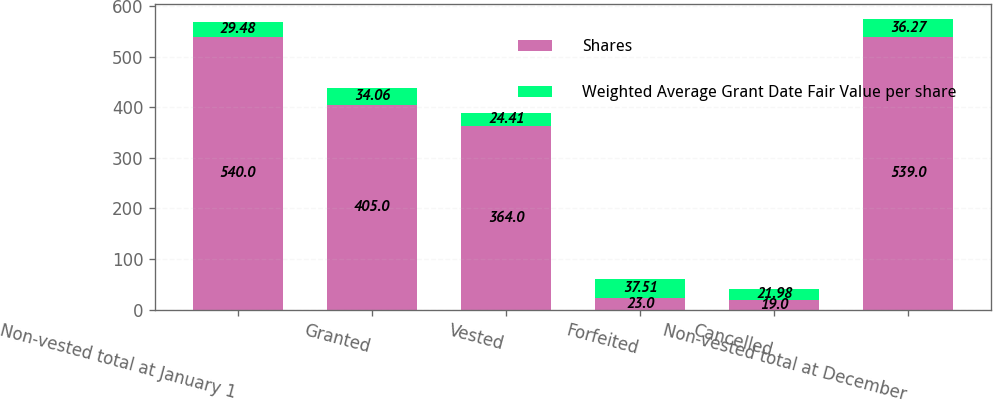Convert chart. <chart><loc_0><loc_0><loc_500><loc_500><stacked_bar_chart><ecel><fcel>Non-vested total at January 1<fcel>Granted<fcel>Vested<fcel>Forfeited<fcel>Cancelled<fcel>Non-vested total at December<nl><fcel>Shares<fcel>540<fcel>405<fcel>364<fcel>23<fcel>19<fcel>539<nl><fcel>Weighted Average Grant Date Fair Value per share<fcel>29.48<fcel>34.06<fcel>24.41<fcel>37.51<fcel>21.98<fcel>36.27<nl></chart> 